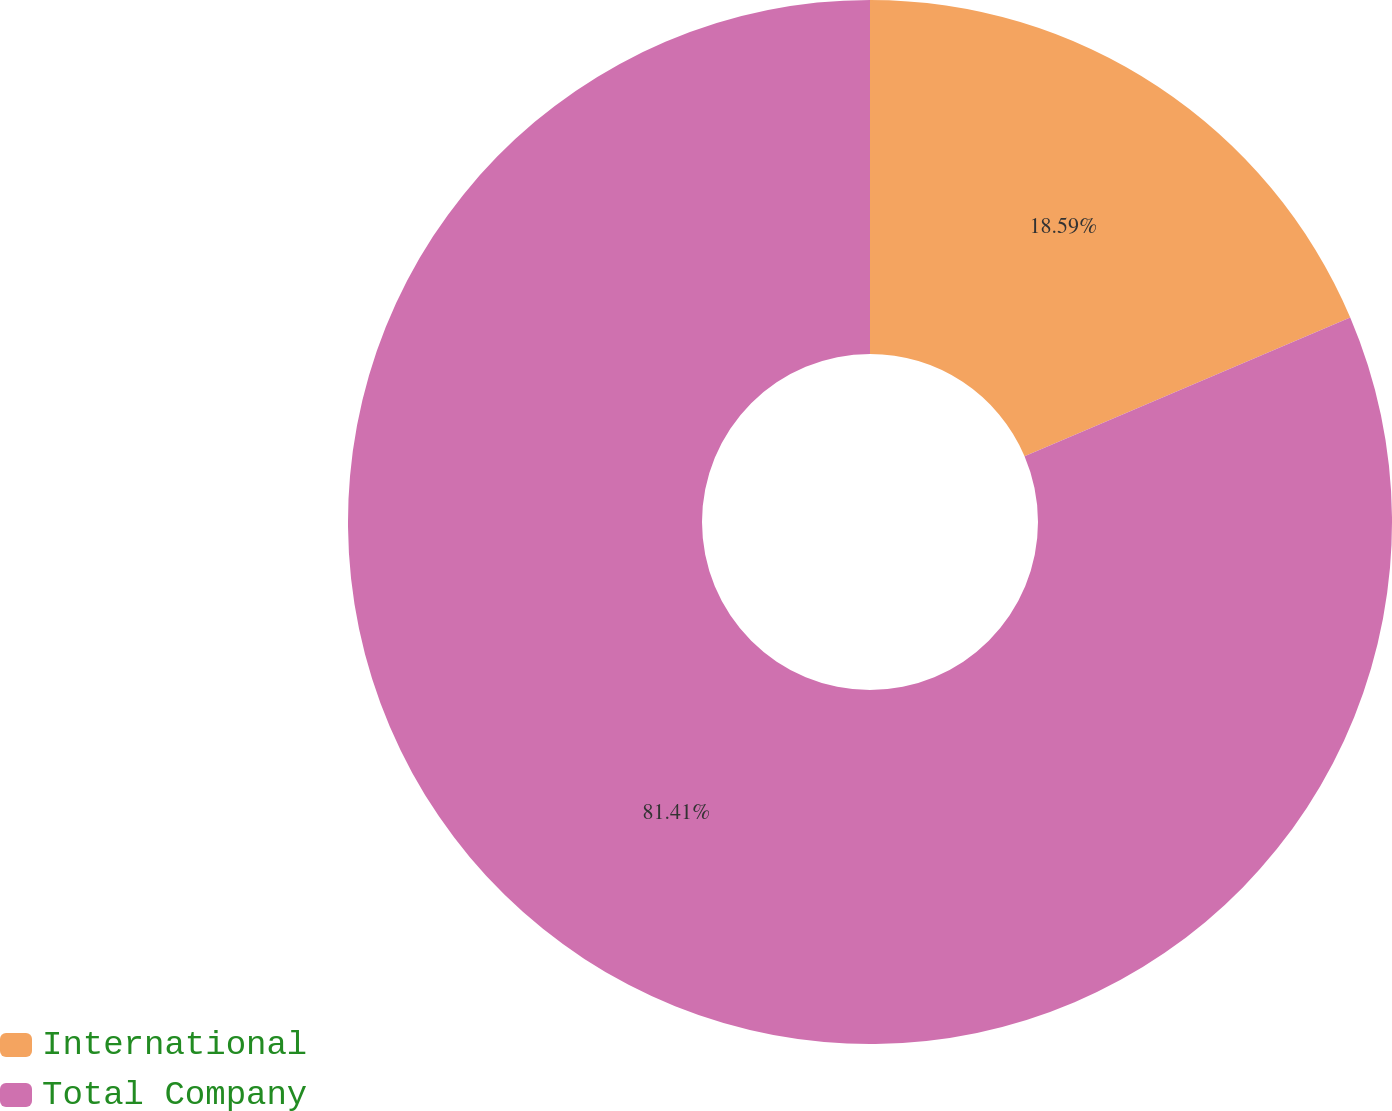<chart> <loc_0><loc_0><loc_500><loc_500><pie_chart><fcel>International<fcel>Total Company<nl><fcel>18.59%<fcel>81.41%<nl></chart> 